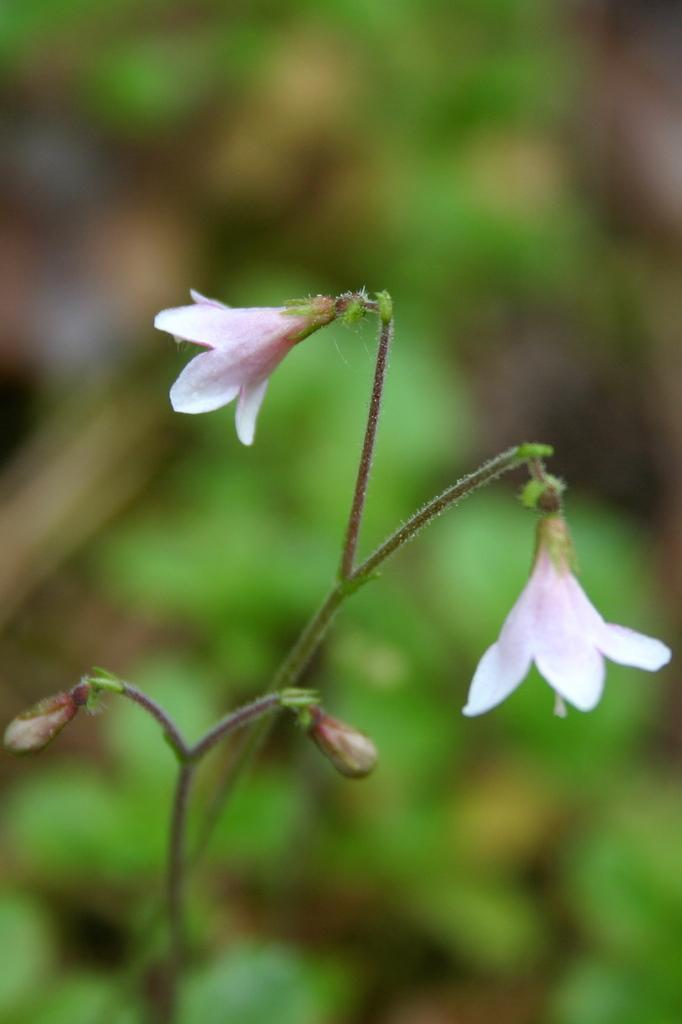What type of plant life is present in the image? There are flowers, buds, and stems in the image. Can you describe the different parts of the plants in the image? The flowers are the colorful parts of the plants, the buds are the unopened flowers, and the stems are the long, thin parts that support the flowers and buds. What is the condition of the background in the image? The background of the image is blurry. What type of chalk is being used to draw on the cork in the image? There is no chalk or cork present in the image; it features flowers, buds, and stems with a blurry background. 